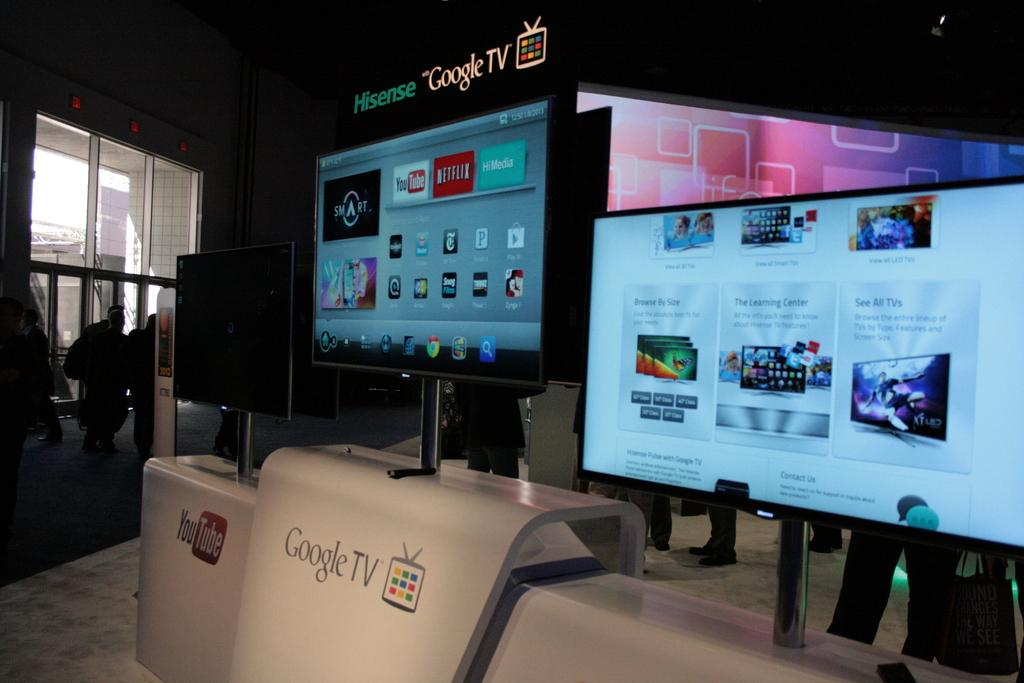<image>
Render a clear and concise summary of the photo. a screen on top of a stand that says 'google tv' on it 